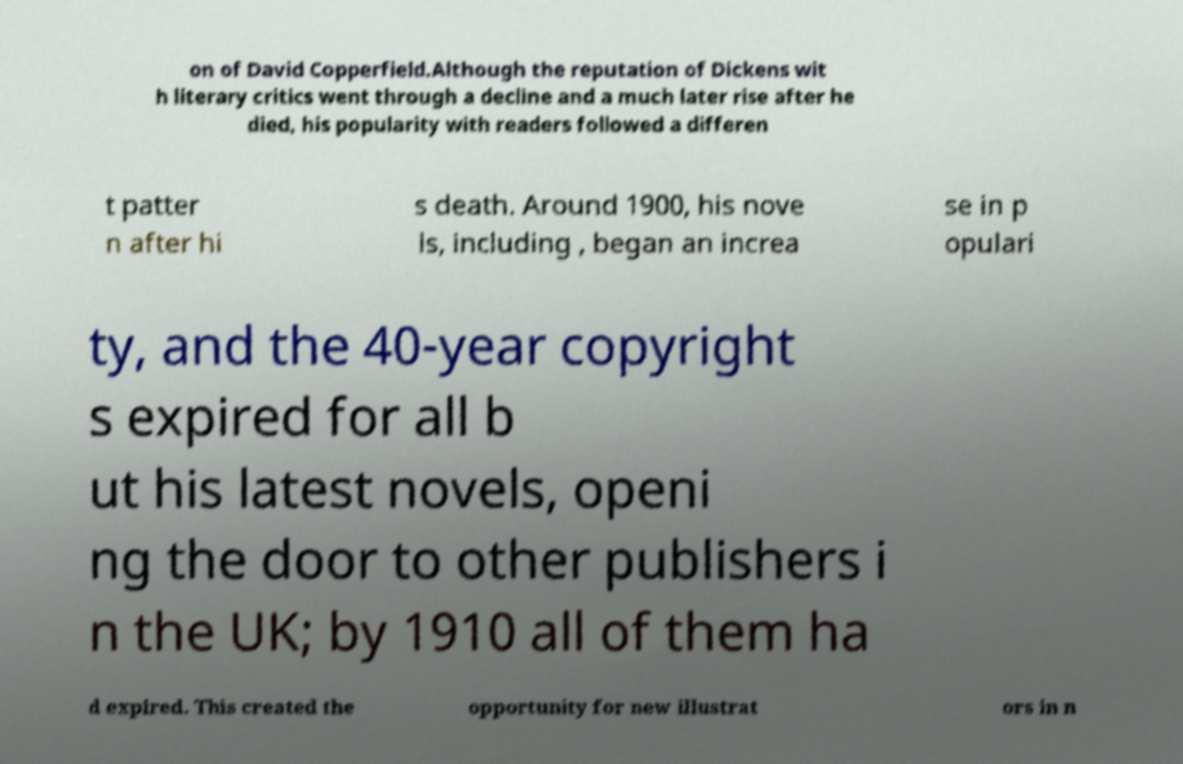What messages or text are displayed in this image? I need them in a readable, typed format. on of David Copperfield.Although the reputation of Dickens wit h literary critics went through a decline and a much later rise after he died, his popularity with readers followed a differen t patter n after hi s death. Around 1900, his nove ls, including , began an increa se in p opulari ty, and the 40-year copyright s expired for all b ut his latest novels, openi ng the door to other publishers i n the UK; by 1910 all of them ha d expired. This created the opportunity for new illustrat ors in n 